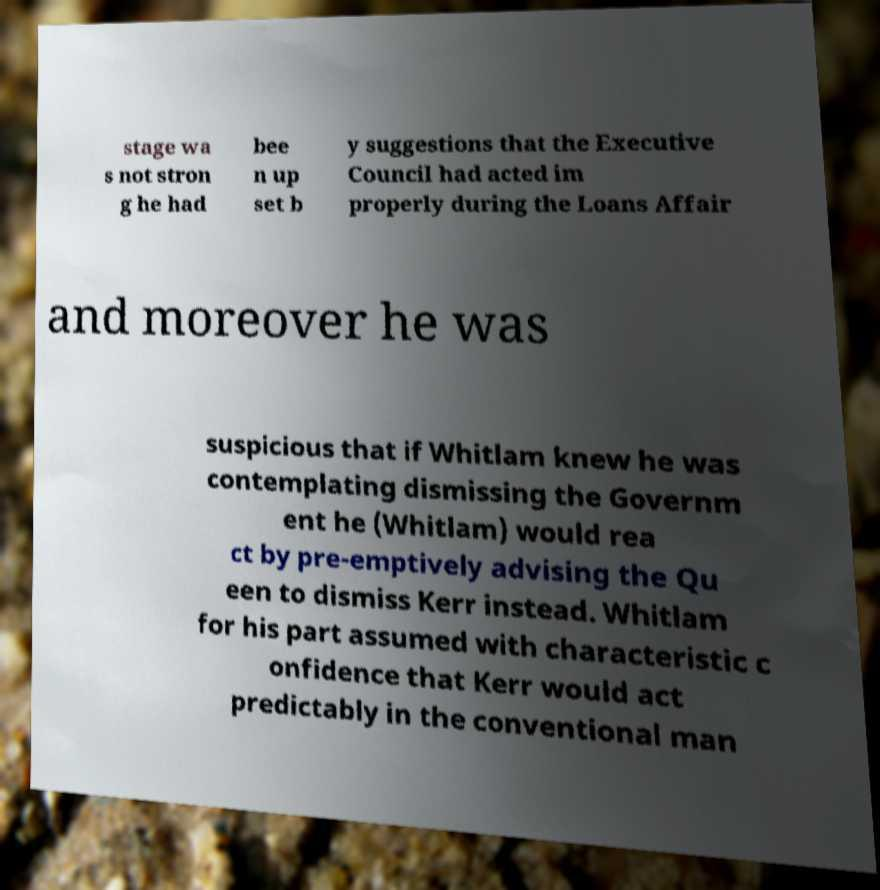Please identify and transcribe the text found in this image. stage wa s not stron g he had bee n up set b y suggestions that the Executive Council had acted im properly during the Loans Affair and moreover he was suspicious that if Whitlam knew he was contemplating dismissing the Governm ent he (Whitlam) would rea ct by pre-emptively advising the Qu een to dismiss Kerr instead. Whitlam for his part assumed with characteristic c onfidence that Kerr would act predictably in the conventional man 